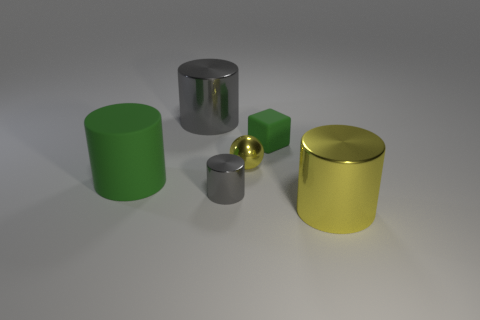Subtract 1 cylinders. How many cylinders are left? 3 Add 3 big cylinders. How many objects exist? 9 Subtract all cubes. How many objects are left? 5 Add 2 big gray metallic things. How many big gray metallic things are left? 3 Add 1 tiny gray cylinders. How many tiny gray cylinders exist? 2 Subtract 0 gray spheres. How many objects are left? 6 Subtract all big blue matte cubes. Subtract all rubber things. How many objects are left? 4 